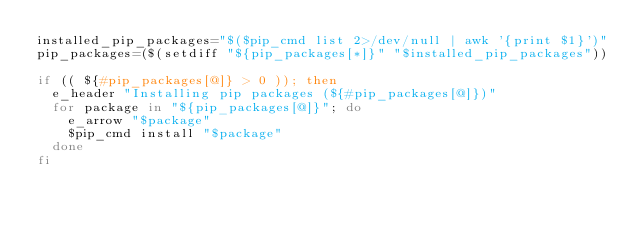<code> <loc_0><loc_0><loc_500><loc_500><_Bash_>installed_pip_packages="$($pip_cmd list 2>/dev/null | awk '{print $1}')"
pip_packages=($(setdiff "${pip_packages[*]}" "$installed_pip_packages"))

if (( ${#pip_packages[@]} > 0 )); then
  e_header "Installing pip packages (${#pip_packages[@]})"
  for package in "${pip_packages[@]}"; do
    e_arrow "$package"
    $pip_cmd install "$package"
  done
fi
</code> 